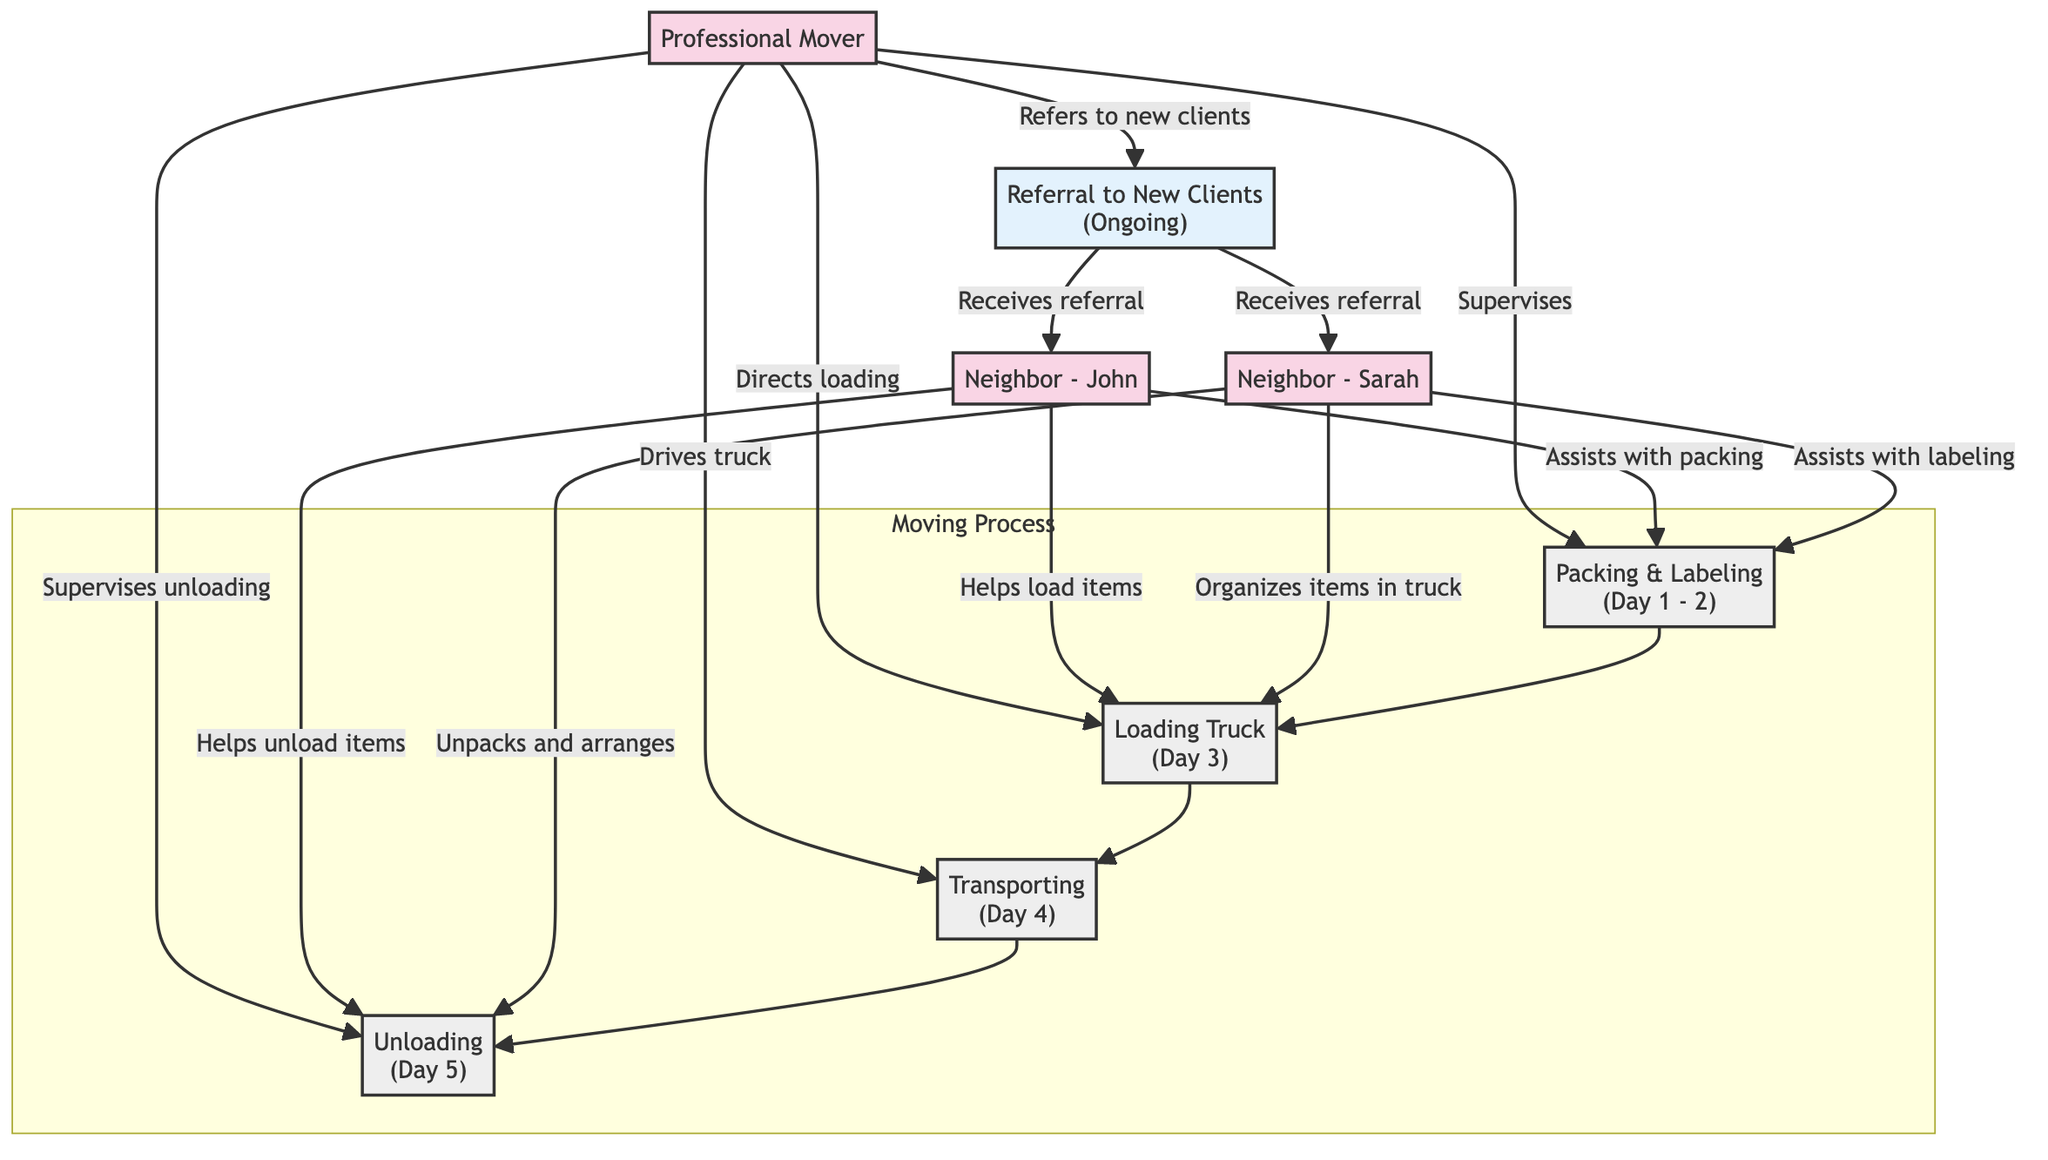What is the first task in the moving process? The diagram shows the sequence of tasks involved in the moving process. The first task listed is "Packing & Labeling," which is indicated as the starting point before loading begins.
Answer: Packing & Labeling How many neighbors are assisting in the moving process? The diagram identifies two neighbors, "John" and "Sarah," indicating their ongoing assistance throughout different tasks during the moving process.
Answer: 2 Which neighbor assists with labeling? The diagram clearly states that "Neighbor - Sarah" is involved in the labeling aspect of the packing task. Thus, she is the one who assists with labeling specifically.
Answer: Sarah What day does loading occur? The diagram specifies that loading is scheduled for "Day 3," which is indicated next to the loading task in the visual layout.
Answer: Day 3 Name the task that involves driving the truck. According to the diagram, "Transporting" is the task that involves the mover driving the truck, indicated in the task sequence following loading.
Answer: Transporting Which tasks does Neighbor - John assist with? By reviewing the diagram, it can be observed that Neighbor - John assists with both packing and loading tasks, as specified.
Answer: Packing, Loading In which task do all participants collaborate? The diagram illustrates that all participants, including the mover and both neighbors, collaborate during the unloading task, indicated by their roles in assisting each other.
Answer: Unloading What ongoing action does the mover take regarding neighbors? The mover continuously provides "Referral to New Clients" to both neighbors as indicated, which is part of the ongoing relationships depicted in the diagram.
Answer: Referral to New Clients 